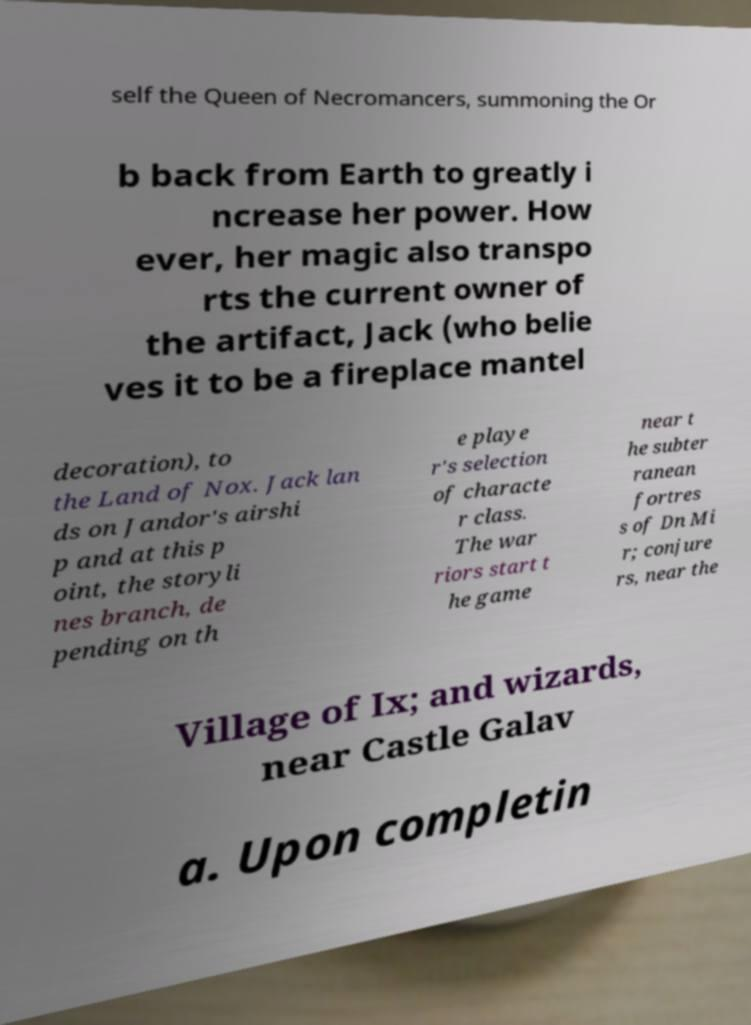For documentation purposes, I need the text within this image transcribed. Could you provide that? self the Queen of Necromancers, summoning the Or b back from Earth to greatly i ncrease her power. How ever, her magic also transpo rts the current owner of the artifact, Jack (who belie ves it to be a fireplace mantel decoration), to the Land of Nox. Jack lan ds on Jandor's airshi p and at this p oint, the storyli nes branch, de pending on th e playe r's selection of characte r class. The war riors start t he game near t he subter ranean fortres s of Dn Mi r; conjure rs, near the Village of Ix; and wizards, near Castle Galav a. Upon completin 